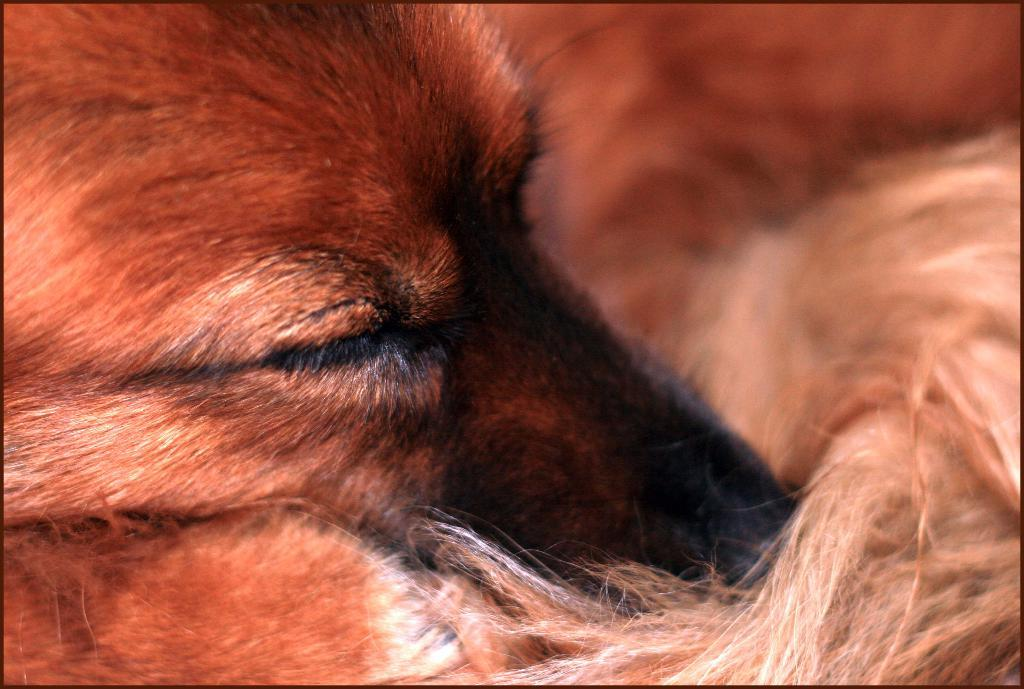What type of animal is in the image? There is a dog in the image. What color is the dog? The dog is brown in color. What is the dog doing in the image? The dog is sleeping. What type of hope can be seen in the image? There is no hope present in the image; it features a brown dog sleeping. What type of hall is visible in the image? There is no hall present in the image; it features a brown dog sleeping. 